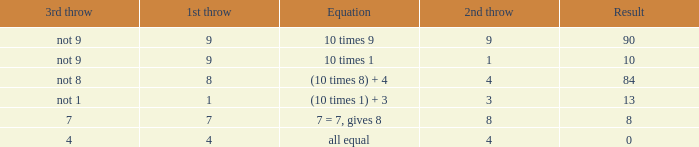If the equation is all equal, what is the 3rd throw? 4.0. 